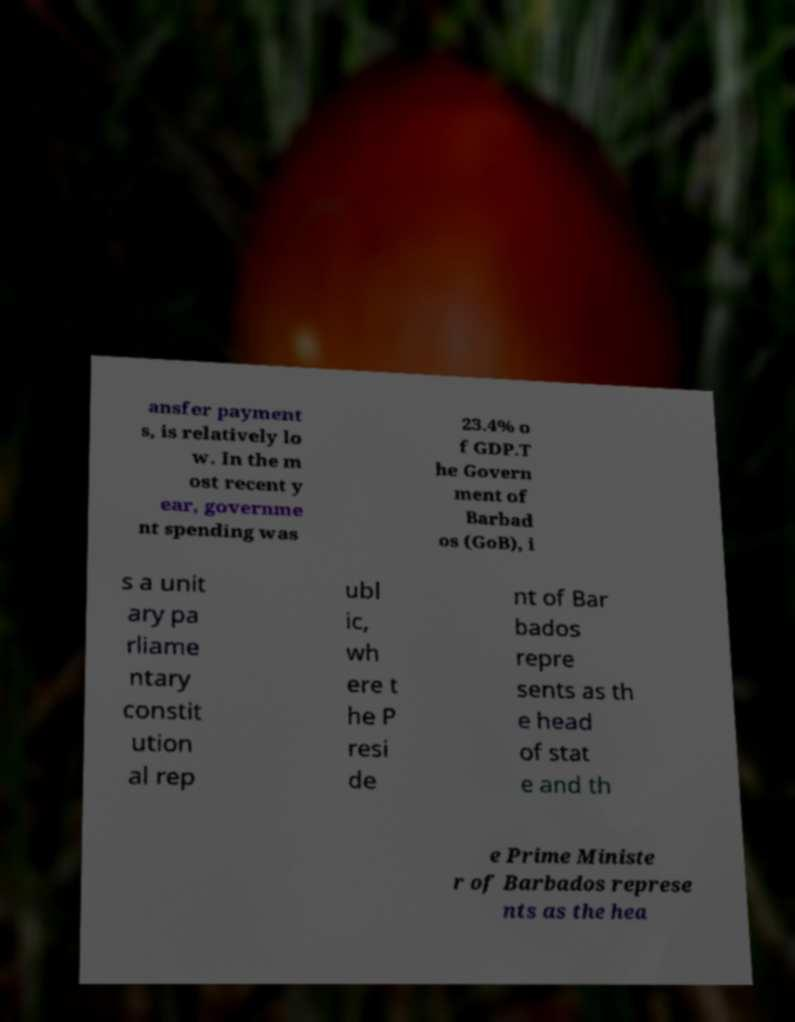There's text embedded in this image that I need extracted. Can you transcribe it verbatim? ansfer payment s, is relatively lo w. In the m ost recent y ear, governme nt spending was 23.4% o f GDP.T he Govern ment of Barbad os (GoB), i s a unit ary pa rliame ntary constit ution al rep ubl ic, wh ere t he P resi de nt of Bar bados repre sents as th e head of stat e and th e Prime Ministe r of Barbados represe nts as the hea 